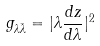<formula> <loc_0><loc_0><loc_500><loc_500>g _ { \lambda \bar { \lambda } } = | \lambda \frac { d z } { d \lambda } | ^ { 2 }</formula> 